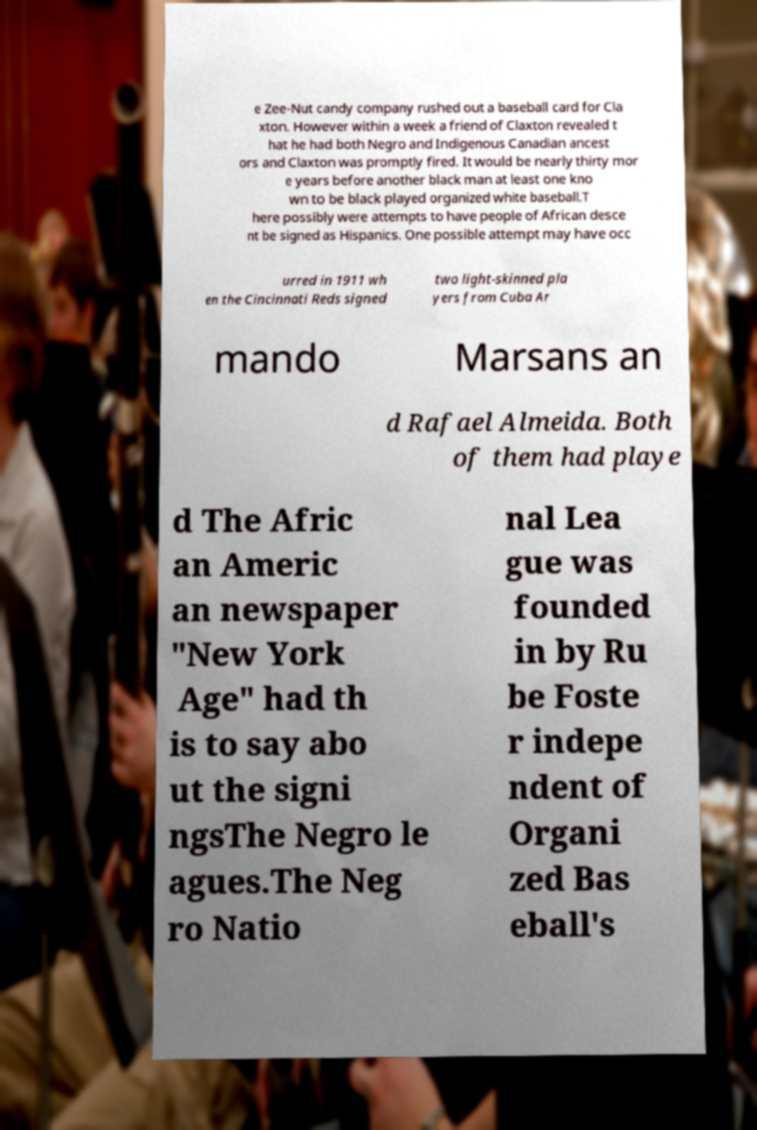There's text embedded in this image that I need extracted. Can you transcribe it verbatim? e Zee-Nut candy company rushed out a baseball card for Cla xton. However within a week a friend of Claxton revealed t hat he had both Negro and Indigenous Canadian ancest ors and Claxton was promptly fired. It would be nearly thirty mor e years before another black man at least one kno wn to be black played organized white baseball.T here possibly were attempts to have people of African desce nt be signed as Hispanics. One possible attempt may have occ urred in 1911 wh en the Cincinnati Reds signed two light-skinned pla yers from Cuba Ar mando Marsans an d Rafael Almeida. Both of them had playe d The Afric an Americ an newspaper "New York Age" had th is to say abo ut the signi ngsThe Negro le agues.The Neg ro Natio nal Lea gue was founded in by Ru be Foste r indepe ndent of Organi zed Bas eball's 